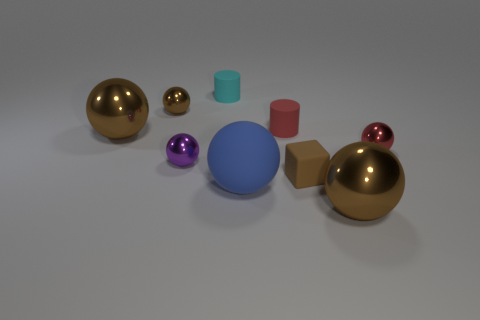How many brown spheres must be subtracted to get 1 brown spheres? 2 Subtract all red cubes. How many brown spheres are left? 3 Subtract all red balls. How many balls are left? 5 Subtract all large blue rubber spheres. How many spheres are left? 5 Subtract all cyan spheres. Subtract all purple blocks. How many spheres are left? 6 Subtract all cylinders. How many objects are left? 7 Subtract 0 purple cubes. How many objects are left? 9 Subtract all tiny red spheres. Subtract all tiny brown spheres. How many objects are left? 7 Add 9 red shiny balls. How many red shiny balls are left? 10 Add 1 cyan objects. How many cyan objects exist? 2 